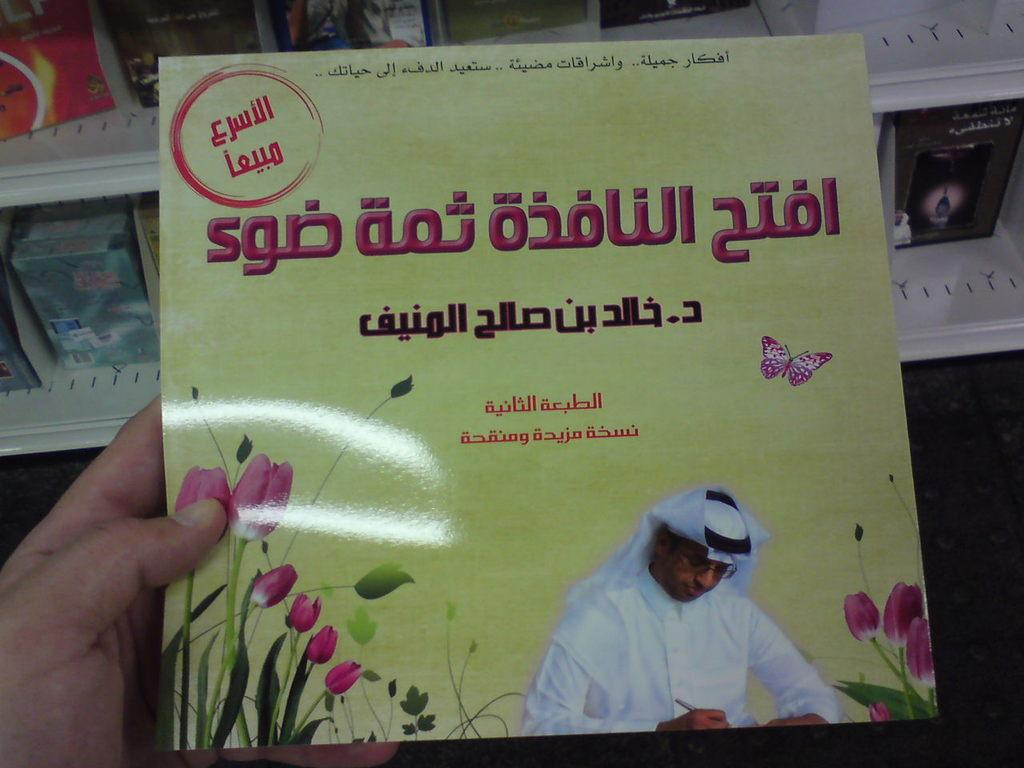What can be seen in the person's hand in the image? The person is holding a card in their hand. What else is visible in the image besides the person's hand? There are objects in racks behind the card. How many dimes are visible on the person's arm in the image? There are no dimes visible on the person's arm in the image. What type of exchange is taking place in the image? There is no exchange taking place in the image; it only shows a person holding a card with objects in racks behind it. 